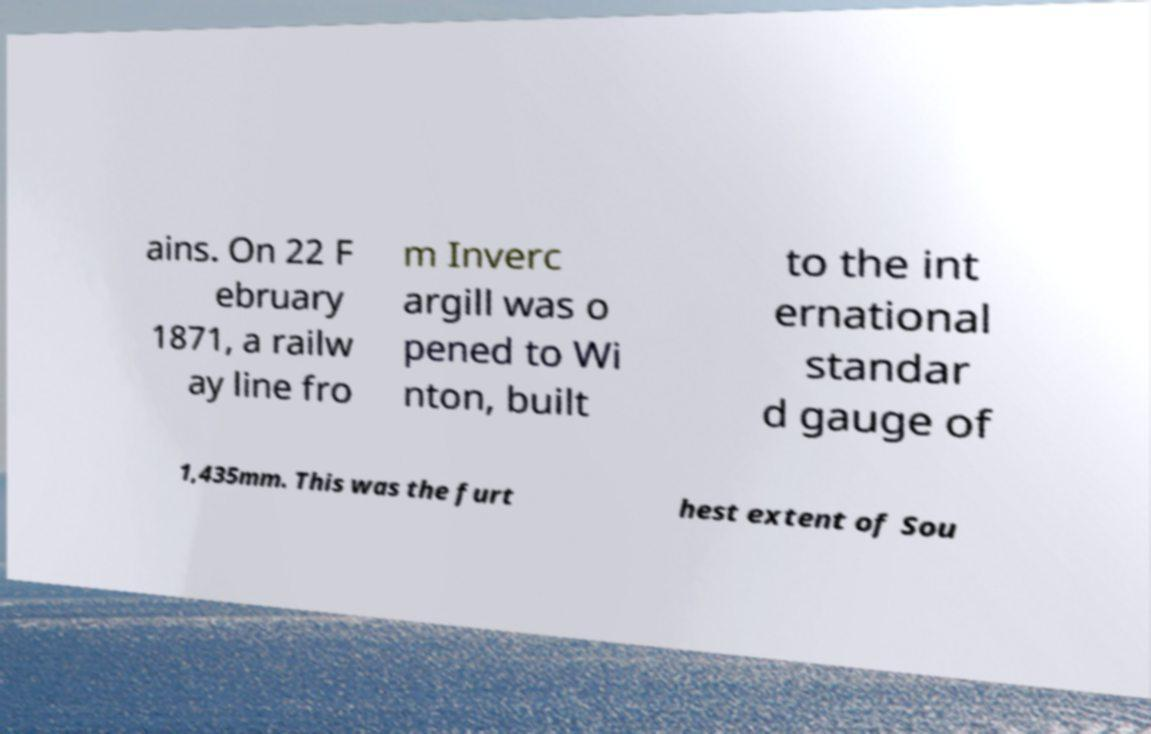What messages or text are displayed in this image? I need them in a readable, typed format. ains. On 22 F ebruary 1871, a railw ay line fro m Inverc argill was o pened to Wi nton, built to the int ernational standar d gauge of 1,435mm. This was the furt hest extent of Sou 